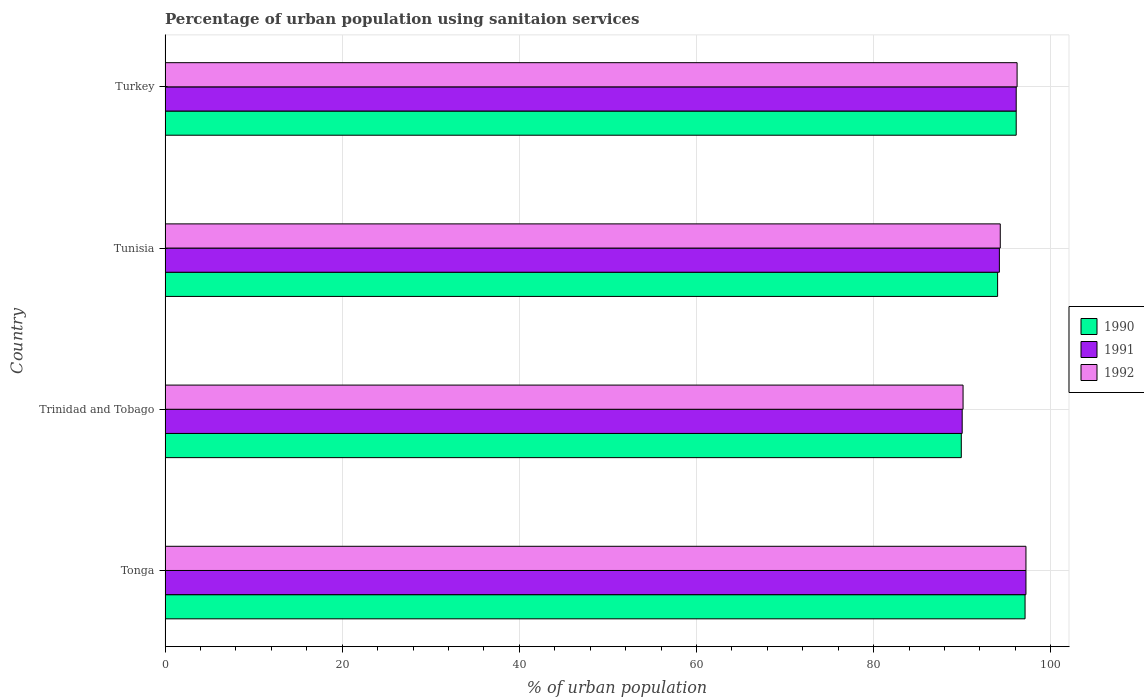How many different coloured bars are there?
Make the answer very short. 3. How many groups of bars are there?
Offer a very short reply. 4. Are the number of bars per tick equal to the number of legend labels?
Make the answer very short. Yes. How many bars are there on the 1st tick from the top?
Make the answer very short. 3. How many bars are there on the 2nd tick from the bottom?
Ensure brevity in your answer.  3. What is the label of the 4th group of bars from the top?
Ensure brevity in your answer.  Tonga. In how many cases, is the number of bars for a given country not equal to the number of legend labels?
Your answer should be compact. 0. What is the percentage of urban population using sanitaion services in 1990 in Tonga?
Your answer should be very brief. 97.1. Across all countries, what is the maximum percentage of urban population using sanitaion services in 1990?
Your answer should be very brief. 97.1. Across all countries, what is the minimum percentage of urban population using sanitaion services in 1992?
Your answer should be very brief. 90.1. In which country was the percentage of urban population using sanitaion services in 1990 maximum?
Your answer should be compact. Tonga. In which country was the percentage of urban population using sanitaion services in 1991 minimum?
Provide a succinct answer. Trinidad and Tobago. What is the total percentage of urban population using sanitaion services in 1992 in the graph?
Your response must be concise. 377.8. What is the difference between the percentage of urban population using sanitaion services in 1992 in Tonga and that in Trinidad and Tobago?
Give a very brief answer. 7.1. What is the difference between the percentage of urban population using sanitaion services in 1990 in Tonga and the percentage of urban population using sanitaion services in 1991 in Trinidad and Tobago?
Provide a succinct answer. 7.1. What is the average percentage of urban population using sanitaion services in 1990 per country?
Offer a terse response. 94.28. What is the difference between the percentage of urban population using sanitaion services in 1990 and percentage of urban population using sanitaion services in 1991 in Tonga?
Your response must be concise. -0.1. In how many countries, is the percentage of urban population using sanitaion services in 1992 greater than 64 %?
Provide a succinct answer. 4. What is the ratio of the percentage of urban population using sanitaion services in 1990 in Tonga to that in Turkey?
Ensure brevity in your answer.  1.01. Is the percentage of urban population using sanitaion services in 1992 in Trinidad and Tobago less than that in Tunisia?
Your answer should be very brief. Yes. What is the difference between the highest and the lowest percentage of urban population using sanitaion services in 1991?
Keep it short and to the point. 7.2. Where does the legend appear in the graph?
Keep it short and to the point. Center right. How are the legend labels stacked?
Provide a succinct answer. Vertical. What is the title of the graph?
Give a very brief answer. Percentage of urban population using sanitaion services. Does "1982" appear as one of the legend labels in the graph?
Provide a succinct answer. No. What is the label or title of the X-axis?
Your answer should be very brief. % of urban population. What is the % of urban population in 1990 in Tonga?
Ensure brevity in your answer.  97.1. What is the % of urban population in 1991 in Tonga?
Make the answer very short. 97.2. What is the % of urban population in 1992 in Tonga?
Provide a short and direct response. 97.2. What is the % of urban population of 1990 in Trinidad and Tobago?
Make the answer very short. 89.9. What is the % of urban population of 1992 in Trinidad and Tobago?
Keep it short and to the point. 90.1. What is the % of urban population in 1990 in Tunisia?
Your answer should be very brief. 94. What is the % of urban population in 1991 in Tunisia?
Provide a succinct answer. 94.2. What is the % of urban population in 1992 in Tunisia?
Ensure brevity in your answer.  94.3. What is the % of urban population in 1990 in Turkey?
Give a very brief answer. 96.1. What is the % of urban population in 1991 in Turkey?
Make the answer very short. 96.1. What is the % of urban population in 1992 in Turkey?
Offer a very short reply. 96.2. Across all countries, what is the maximum % of urban population in 1990?
Your answer should be compact. 97.1. Across all countries, what is the maximum % of urban population in 1991?
Offer a very short reply. 97.2. Across all countries, what is the maximum % of urban population of 1992?
Give a very brief answer. 97.2. Across all countries, what is the minimum % of urban population of 1990?
Provide a short and direct response. 89.9. Across all countries, what is the minimum % of urban population of 1991?
Your answer should be compact. 90. Across all countries, what is the minimum % of urban population of 1992?
Your answer should be very brief. 90.1. What is the total % of urban population in 1990 in the graph?
Give a very brief answer. 377.1. What is the total % of urban population of 1991 in the graph?
Keep it short and to the point. 377.5. What is the total % of urban population of 1992 in the graph?
Your answer should be compact. 377.8. What is the difference between the % of urban population of 1990 in Tonga and that in Trinidad and Tobago?
Make the answer very short. 7.2. What is the difference between the % of urban population in 1991 in Tonga and that in Trinidad and Tobago?
Provide a succinct answer. 7.2. What is the difference between the % of urban population of 1992 in Tonga and that in Trinidad and Tobago?
Make the answer very short. 7.1. What is the difference between the % of urban population in 1990 in Tonga and that in Turkey?
Your response must be concise. 1. What is the difference between the % of urban population in 1992 in Tonga and that in Turkey?
Keep it short and to the point. 1. What is the difference between the % of urban population of 1990 in Trinidad and Tobago and that in Tunisia?
Your answer should be very brief. -4.1. What is the difference between the % of urban population in 1992 in Trinidad and Tobago and that in Tunisia?
Your answer should be very brief. -4.2. What is the difference between the % of urban population in 1990 in Trinidad and Tobago and that in Turkey?
Make the answer very short. -6.2. What is the difference between the % of urban population in 1991 in Trinidad and Tobago and that in Turkey?
Offer a terse response. -6.1. What is the difference between the % of urban population of 1991 in Tunisia and that in Turkey?
Your answer should be very brief. -1.9. What is the difference between the % of urban population of 1990 in Tonga and the % of urban population of 1991 in Trinidad and Tobago?
Provide a succinct answer. 7.1. What is the difference between the % of urban population of 1991 in Tonga and the % of urban population of 1992 in Trinidad and Tobago?
Ensure brevity in your answer.  7.1. What is the difference between the % of urban population in 1990 in Tonga and the % of urban population in 1992 in Tunisia?
Offer a very short reply. 2.8. What is the difference between the % of urban population in 1991 in Tonga and the % of urban population in 1992 in Tunisia?
Make the answer very short. 2.9. What is the difference between the % of urban population in 1990 in Trinidad and Tobago and the % of urban population in 1992 in Tunisia?
Your answer should be very brief. -4.4. What is the difference between the % of urban population in 1991 in Trinidad and Tobago and the % of urban population in 1992 in Tunisia?
Your answer should be very brief. -4.3. What is the difference between the % of urban population of 1991 in Tunisia and the % of urban population of 1992 in Turkey?
Provide a short and direct response. -2. What is the average % of urban population in 1990 per country?
Your answer should be very brief. 94.28. What is the average % of urban population of 1991 per country?
Provide a short and direct response. 94.38. What is the average % of urban population of 1992 per country?
Your answer should be very brief. 94.45. What is the difference between the % of urban population of 1990 and % of urban population of 1991 in Tonga?
Give a very brief answer. -0.1. What is the difference between the % of urban population of 1991 and % of urban population of 1992 in Tonga?
Your response must be concise. 0. What is the difference between the % of urban population of 1991 and % of urban population of 1992 in Trinidad and Tobago?
Your answer should be very brief. -0.1. What is the difference between the % of urban population in 1991 and % of urban population in 1992 in Tunisia?
Provide a succinct answer. -0.1. What is the difference between the % of urban population in 1991 and % of urban population in 1992 in Turkey?
Ensure brevity in your answer.  -0.1. What is the ratio of the % of urban population of 1990 in Tonga to that in Trinidad and Tobago?
Give a very brief answer. 1.08. What is the ratio of the % of urban population in 1991 in Tonga to that in Trinidad and Tobago?
Offer a very short reply. 1.08. What is the ratio of the % of urban population in 1992 in Tonga to that in Trinidad and Tobago?
Provide a short and direct response. 1.08. What is the ratio of the % of urban population in 1990 in Tonga to that in Tunisia?
Offer a very short reply. 1.03. What is the ratio of the % of urban population in 1991 in Tonga to that in Tunisia?
Give a very brief answer. 1.03. What is the ratio of the % of urban population in 1992 in Tonga to that in Tunisia?
Provide a succinct answer. 1.03. What is the ratio of the % of urban population of 1990 in Tonga to that in Turkey?
Provide a succinct answer. 1.01. What is the ratio of the % of urban population in 1991 in Tonga to that in Turkey?
Your response must be concise. 1.01. What is the ratio of the % of urban population in 1992 in Tonga to that in Turkey?
Offer a very short reply. 1.01. What is the ratio of the % of urban population of 1990 in Trinidad and Tobago to that in Tunisia?
Offer a terse response. 0.96. What is the ratio of the % of urban population of 1991 in Trinidad and Tobago to that in Tunisia?
Your answer should be compact. 0.96. What is the ratio of the % of urban population in 1992 in Trinidad and Tobago to that in Tunisia?
Provide a short and direct response. 0.96. What is the ratio of the % of urban population in 1990 in Trinidad and Tobago to that in Turkey?
Provide a short and direct response. 0.94. What is the ratio of the % of urban population of 1991 in Trinidad and Tobago to that in Turkey?
Provide a short and direct response. 0.94. What is the ratio of the % of urban population in 1992 in Trinidad and Tobago to that in Turkey?
Give a very brief answer. 0.94. What is the ratio of the % of urban population of 1990 in Tunisia to that in Turkey?
Your response must be concise. 0.98. What is the ratio of the % of urban population of 1991 in Tunisia to that in Turkey?
Your answer should be compact. 0.98. What is the ratio of the % of urban population in 1992 in Tunisia to that in Turkey?
Offer a terse response. 0.98. What is the difference between the highest and the second highest % of urban population of 1990?
Provide a short and direct response. 1. What is the difference between the highest and the second highest % of urban population of 1992?
Keep it short and to the point. 1. What is the difference between the highest and the lowest % of urban population in 1990?
Give a very brief answer. 7.2. What is the difference between the highest and the lowest % of urban population in 1991?
Offer a very short reply. 7.2. 